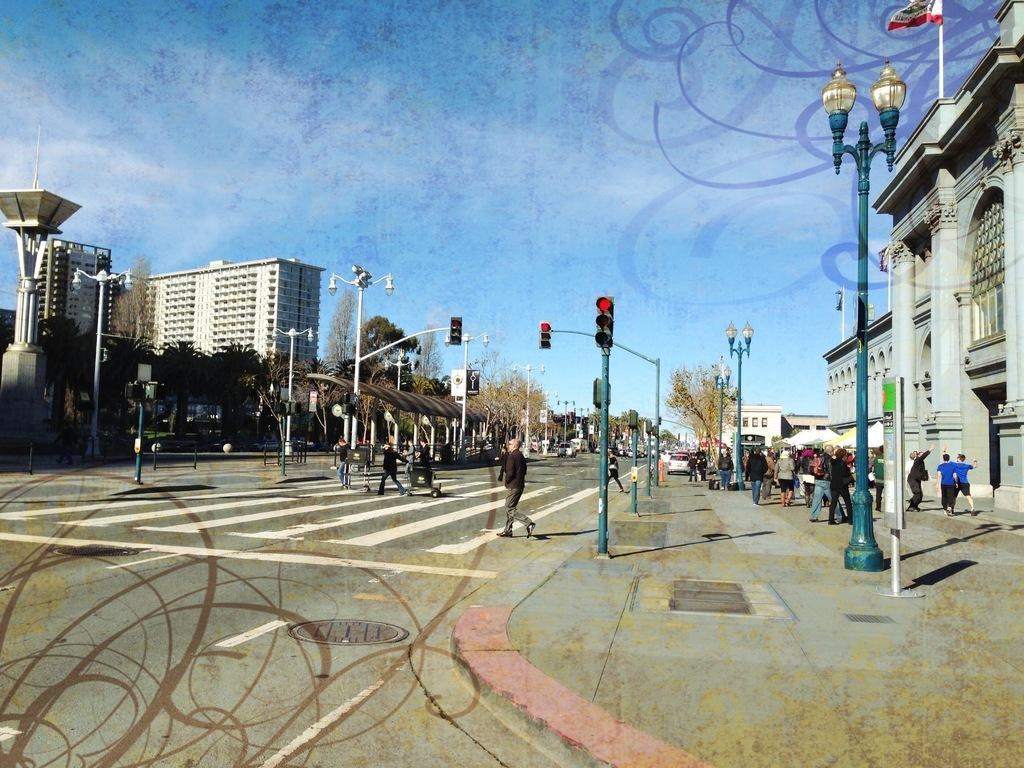Please provide a concise description of this image. In the image we can see there are people standing on the footpath and road. There are street light poles on the footpath and there are lot of trees. Behind there are buildings. 